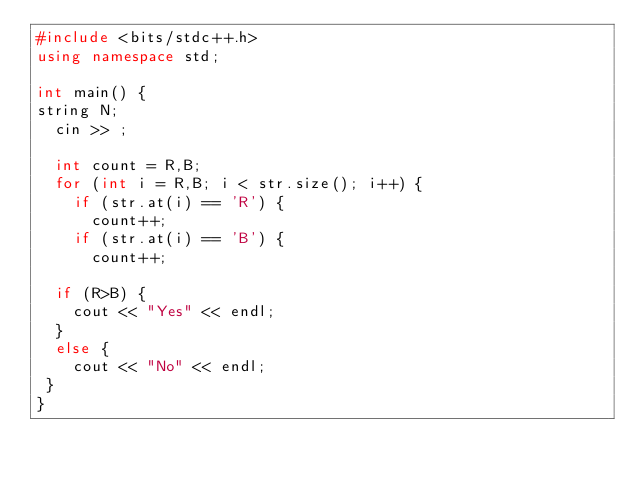Convert code to text. <code><loc_0><loc_0><loc_500><loc_500><_C++_>#include <bits/stdc++.h>
using namespace std;

int main() {
string N;
  cin >> ;
 
  int count = R,B;
  for (int i = R,B; i < str.size(); i++) {
    if (str.at(i) == 'R') {
      count++;
    if (str.at(i) == 'B') {
      count++;

  if (R>B) {
    cout << "Yes" << endl;
  }
  else {
    cout << "No" << endl;
 }
}



</code> 